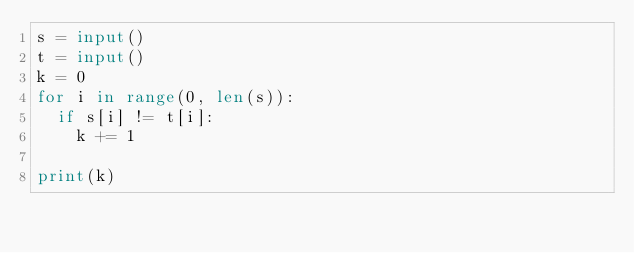Convert code to text. <code><loc_0><loc_0><loc_500><loc_500><_Python_>s = input()
t = input()
k = 0
for i in range(0, len(s)):
  if s[i] != t[i]:
    k += 1
    
print(k)</code> 